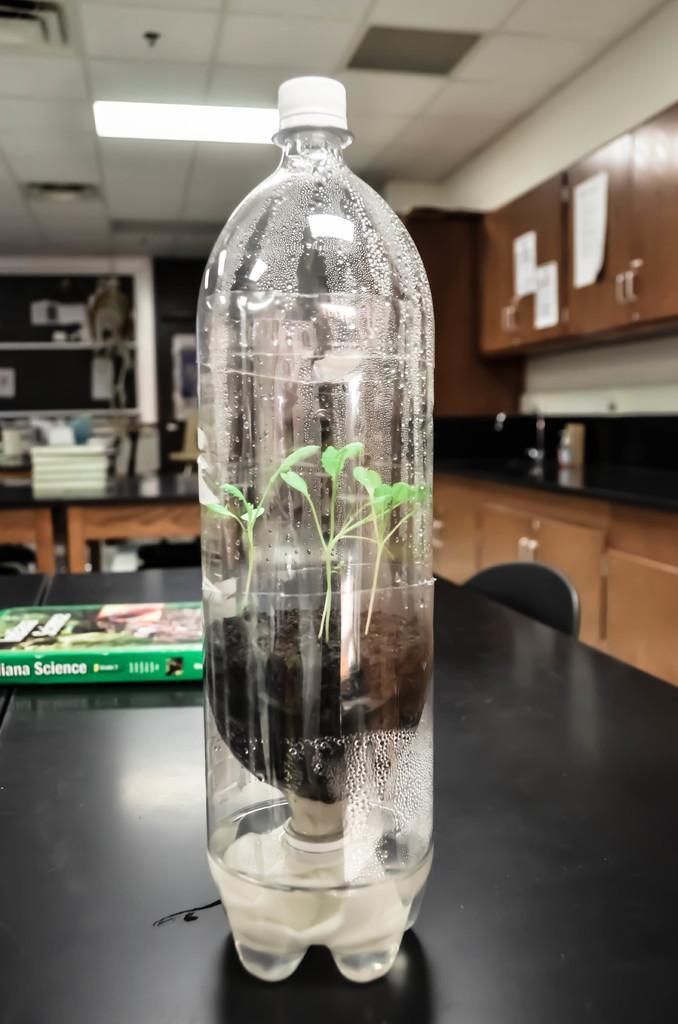Could you give a brief overview of what you see in this image? In this picture we have a bottle on the table in which there is a plant and a book on the table. 